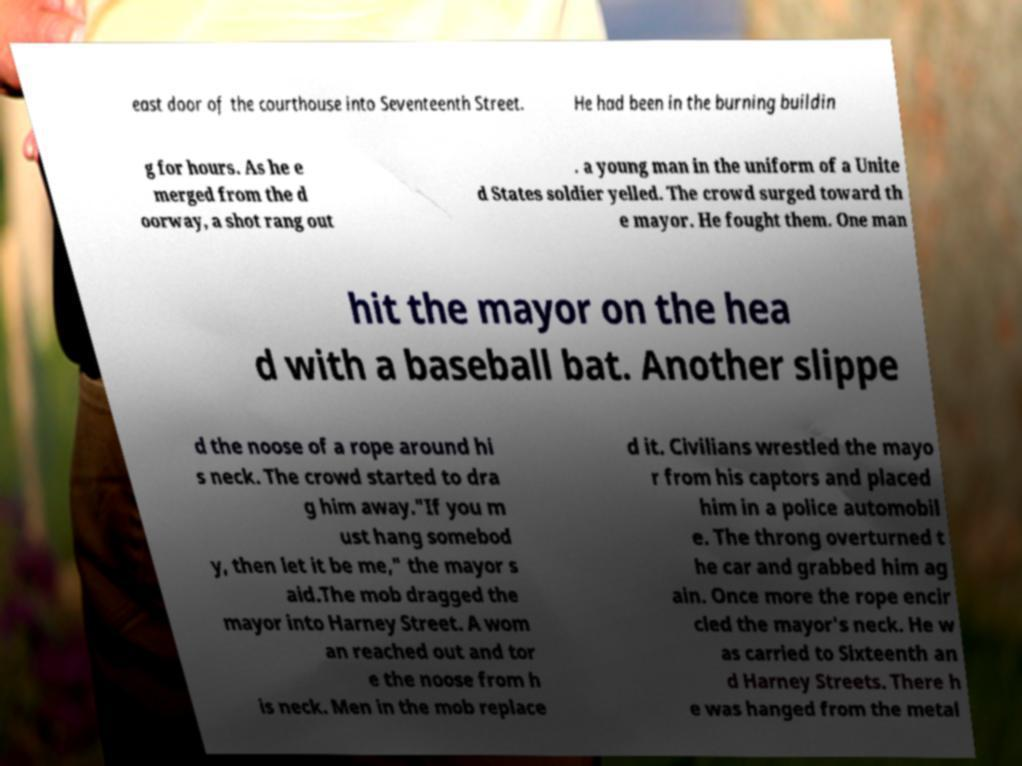For documentation purposes, I need the text within this image transcribed. Could you provide that? east door of the courthouse into Seventeenth Street. He had been in the burning buildin g for hours. As he e merged from the d oorway, a shot rang out . a young man in the uniform of a Unite d States soldier yelled. The crowd surged toward th e mayor. He fought them. One man hit the mayor on the hea d with a baseball bat. Another slippe d the noose of a rope around hi s neck. The crowd started to dra g him away."If you m ust hang somebod y, then let it be me," the mayor s aid.The mob dragged the mayor into Harney Street. A wom an reached out and tor e the noose from h is neck. Men in the mob replace d it. Civilians wrestled the mayo r from his captors and placed him in a police automobil e. The throng overturned t he car and grabbed him ag ain. Once more the rope encir cled the mayor's neck. He w as carried to Sixteenth an d Harney Streets. There h e was hanged from the metal 